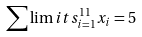Convert formula to latex. <formula><loc_0><loc_0><loc_500><loc_500>\sum \lim i t s _ { i = 1 } ^ { 1 1 } x _ { i } = 5</formula> 